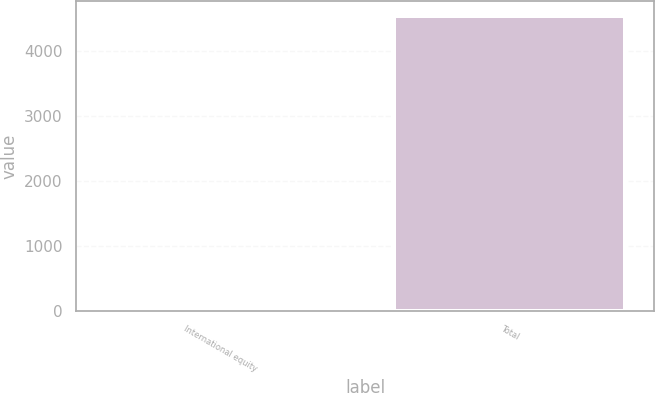<chart> <loc_0><loc_0><loc_500><loc_500><bar_chart><fcel>International equity<fcel>Total<nl><fcel>10<fcel>4533<nl></chart> 